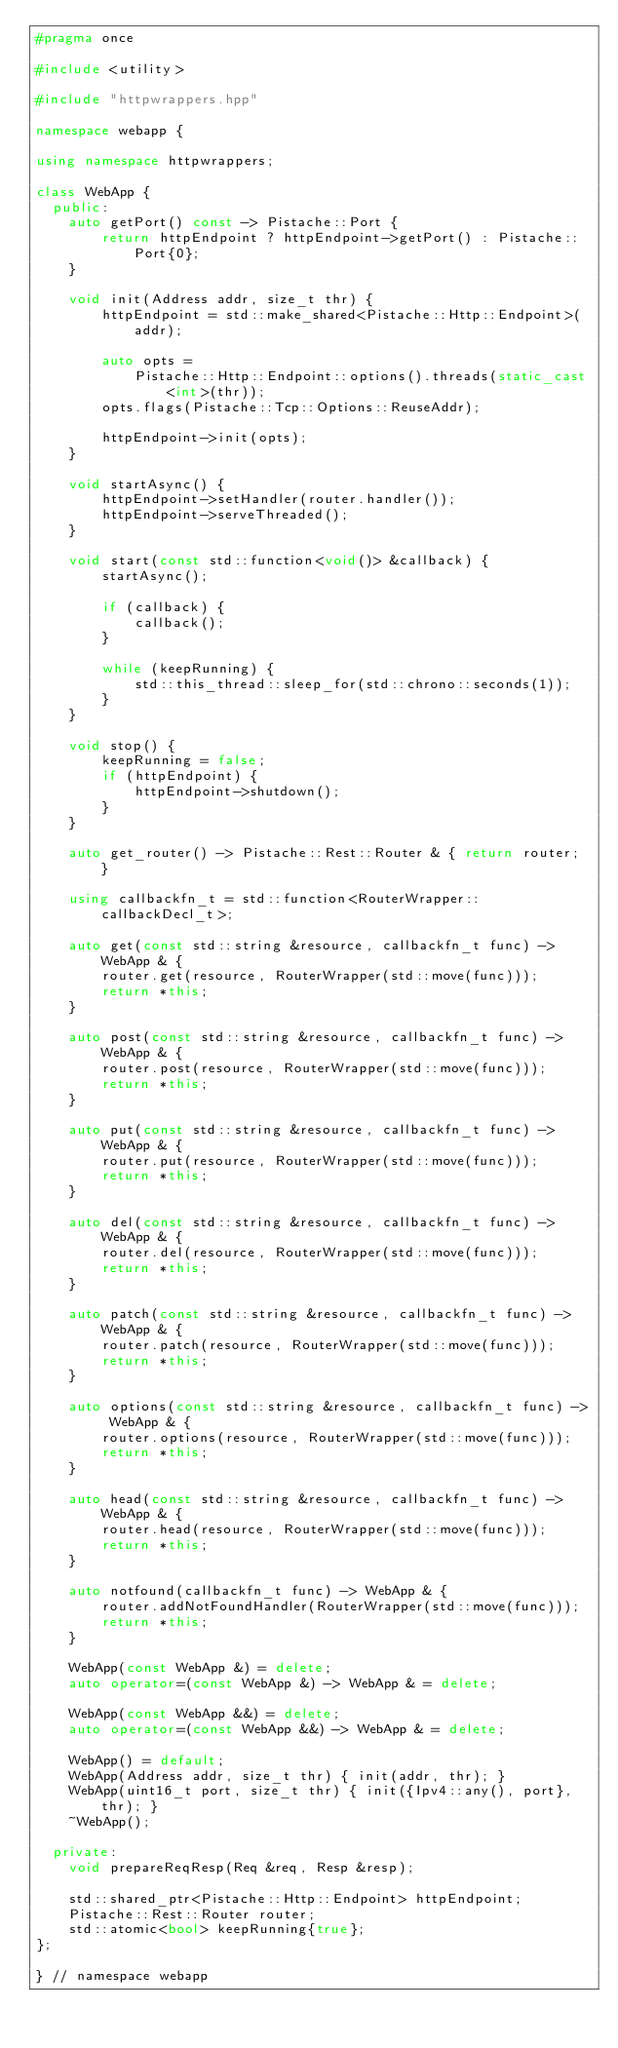<code> <loc_0><loc_0><loc_500><loc_500><_C++_>#pragma once

#include <utility>

#include "httpwrappers.hpp"

namespace webapp {

using namespace httpwrappers;

class WebApp {
  public:
    auto getPort() const -> Pistache::Port {
        return httpEndpoint ? httpEndpoint->getPort() : Pistache::Port{0};
    }

    void init(Address addr, size_t thr) {
        httpEndpoint = std::make_shared<Pistache::Http::Endpoint>(addr);

        auto opts =
            Pistache::Http::Endpoint::options().threads(static_cast<int>(thr));
        opts.flags(Pistache::Tcp::Options::ReuseAddr);

        httpEndpoint->init(opts);
    }

    void startAsync() {
        httpEndpoint->setHandler(router.handler());
        httpEndpoint->serveThreaded();
    }

    void start(const std::function<void()> &callback) {
        startAsync();

        if (callback) {
            callback();
        }

        while (keepRunning) {
            std::this_thread::sleep_for(std::chrono::seconds(1));
        }
    }

    void stop() {
        keepRunning = false;
        if (httpEndpoint) {
            httpEndpoint->shutdown();
        }
    }

    auto get_router() -> Pistache::Rest::Router & { return router; }

    using callbackfn_t = std::function<RouterWrapper::callbackDecl_t>;

    auto get(const std::string &resource, callbackfn_t func) -> WebApp & {
        router.get(resource, RouterWrapper(std::move(func)));
        return *this;
    }

    auto post(const std::string &resource, callbackfn_t func) -> WebApp & {
        router.post(resource, RouterWrapper(std::move(func)));
        return *this;
    }

    auto put(const std::string &resource, callbackfn_t func) -> WebApp & {
        router.put(resource, RouterWrapper(std::move(func)));
        return *this;
    }

    auto del(const std::string &resource, callbackfn_t func) -> WebApp & {
        router.del(resource, RouterWrapper(std::move(func)));
        return *this;
    }

    auto patch(const std::string &resource, callbackfn_t func) -> WebApp & {
        router.patch(resource, RouterWrapper(std::move(func)));
        return *this;
    }

    auto options(const std::string &resource, callbackfn_t func) -> WebApp & {
        router.options(resource, RouterWrapper(std::move(func)));
        return *this;
    }

    auto head(const std::string &resource, callbackfn_t func) -> WebApp & {
        router.head(resource, RouterWrapper(std::move(func)));
        return *this;
    }

    auto notfound(callbackfn_t func) -> WebApp & {
        router.addNotFoundHandler(RouterWrapper(std::move(func)));
        return *this;
    }

    WebApp(const WebApp &) = delete;
    auto operator=(const WebApp &) -> WebApp & = delete;

    WebApp(const WebApp &&) = delete;
    auto operator=(const WebApp &&) -> WebApp & = delete;

    WebApp() = default;
    WebApp(Address addr, size_t thr) { init(addr, thr); }
    WebApp(uint16_t port, size_t thr) { init({Ipv4::any(), port}, thr); }
    ~WebApp();

  private:
    void prepareReqResp(Req &req, Resp &resp);

    std::shared_ptr<Pistache::Http::Endpoint> httpEndpoint;
    Pistache::Rest::Router router;
    std::atomic<bool> keepRunning{true};
};

} // namespace webapp
</code> 